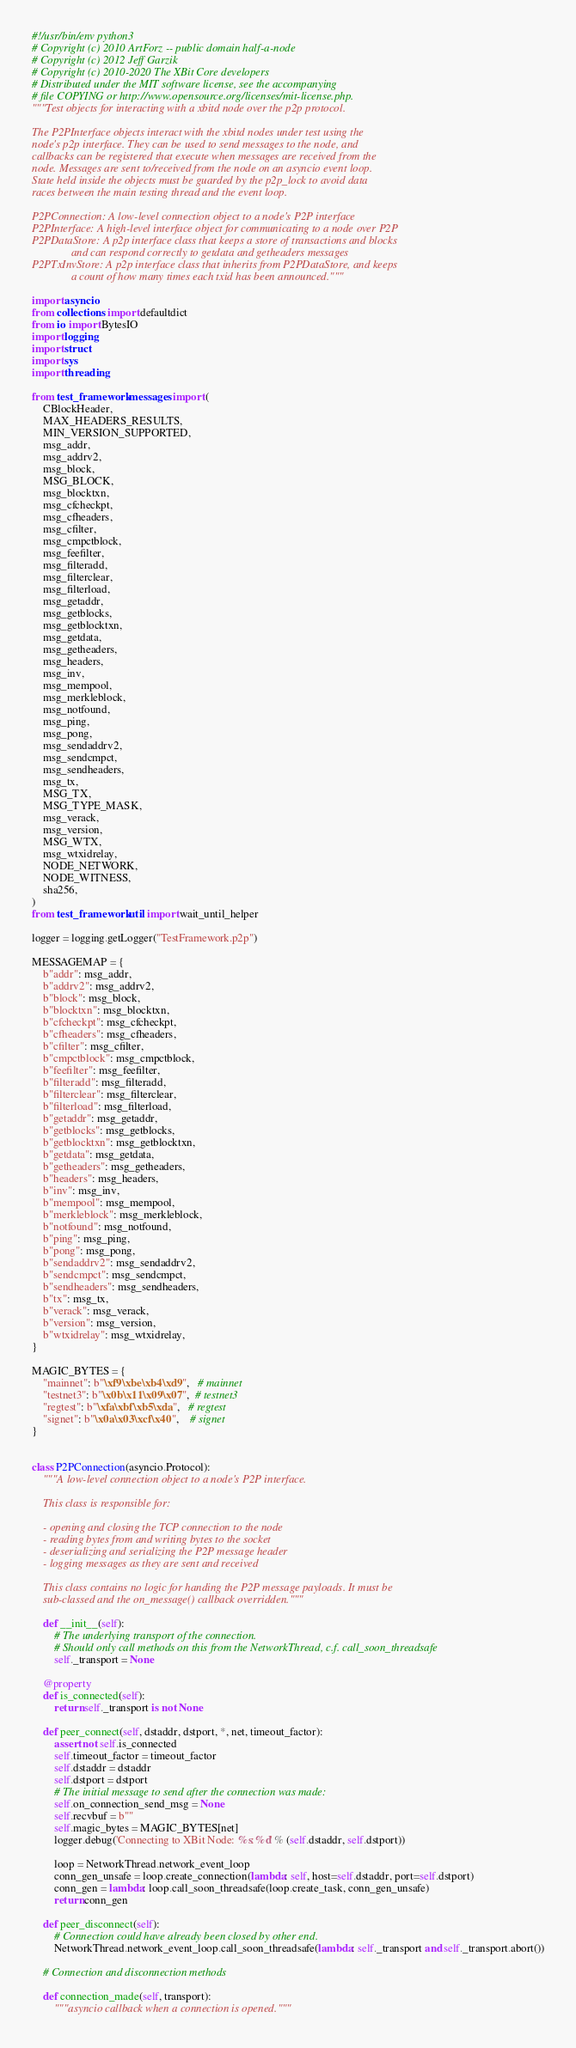Convert code to text. <code><loc_0><loc_0><loc_500><loc_500><_Python_>#!/usr/bin/env python3
# Copyright (c) 2010 ArtForz -- public domain half-a-node
# Copyright (c) 2012 Jeff Garzik
# Copyright (c) 2010-2020 The XBit Core developers
# Distributed under the MIT software license, see the accompanying
# file COPYING or http://www.opensource.org/licenses/mit-license.php.
"""Test objects for interacting with a xbitd node over the p2p protocol.

The P2PInterface objects interact with the xbitd nodes under test using the
node's p2p interface. They can be used to send messages to the node, and
callbacks can be registered that execute when messages are received from the
node. Messages are sent to/received from the node on an asyncio event loop.
State held inside the objects must be guarded by the p2p_lock to avoid data
races between the main testing thread and the event loop.

P2PConnection: A low-level connection object to a node's P2P interface
P2PInterface: A high-level interface object for communicating to a node over P2P
P2PDataStore: A p2p interface class that keeps a store of transactions and blocks
              and can respond correctly to getdata and getheaders messages
P2PTxInvStore: A p2p interface class that inherits from P2PDataStore, and keeps
              a count of how many times each txid has been announced."""

import asyncio
from collections import defaultdict
from io import BytesIO
import logging
import struct
import sys
import threading

from test_framework.messages import (
    CBlockHeader,
    MAX_HEADERS_RESULTS,
    MIN_VERSION_SUPPORTED,
    msg_addr,
    msg_addrv2,
    msg_block,
    MSG_BLOCK,
    msg_blocktxn,
    msg_cfcheckpt,
    msg_cfheaders,
    msg_cfilter,
    msg_cmpctblock,
    msg_feefilter,
    msg_filteradd,
    msg_filterclear,
    msg_filterload,
    msg_getaddr,
    msg_getblocks,
    msg_getblocktxn,
    msg_getdata,
    msg_getheaders,
    msg_headers,
    msg_inv,
    msg_mempool,
    msg_merkleblock,
    msg_notfound,
    msg_ping,
    msg_pong,
    msg_sendaddrv2,
    msg_sendcmpct,
    msg_sendheaders,
    msg_tx,
    MSG_TX,
    MSG_TYPE_MASK,
    msg_verack,
    msg_version,
    MSG_WTX,
    msg_wtxidrelay,
    NODE_NETWORK,
    NODE_WITNESS,
    sha256,
)
from test_framework.util import wait_until_helper

logger = logging.getLogger("TestFramework.p2p")

MESSAGEMAP = {
    b"addr": msg_addr,
    b"addrv2": msg_addrv2,
    b"block": msg_block,
    b"blocktxn": msg_blocktxn,
    b"cfcheckpt": msg_cfcheckpt,
    b"cfheaders": msg_cfheaders,
    b"cfilter": msg_cfilter,
    b"cmpctblock": msg_cmpctblock,
    b"feefilter": msg_feefilter,
    b"filteradd": msg_filteradd,
    b"filterclear": msg_filterclear,
    b"filterload": msg_filterload,
    b"getaddr": msg_getaddr,
    b"getblocks": msg_getblocks,
    b"getblocktxn": msg_getblocktxn,
    b"getdata": msg_getdata,
    b"getheaders": msg_getheaders,
    b"headers": msg_headers,
    b"inv": msg_inv,
    b"mempool": msg_mempool,
    b"merkleblock": msg_merkleblock,
    b"notfound": msg_notfound,
    b"ping": msg_ping,
    b"pong": msg_pong,
    b"sendaddrv2": msg_sendaddrv2,
    b"sendcmpct": msg_sendcmpct,
    b"sendheaders": msg_sendheaders,
    b"tx": msg_tx,
    b"verack": msg_verack,
    b"version": msg_version,
    b"wtxidrelay": msg_wtxidrelay,
}

MAGIC_BYTES = {
    "mainnet": b"\xf9\xbe\xb4\xd9",   # mainnet
    "testnet3": b"\x0b\x11\x09\x07",  # testnet3
    "regtest": b"\xfa\xbf\xb5\xda",   # regtest
    "signet": b"\x0a\x03\xcf\x40",    # signet
}


class P2PConnection(asyncio.Protocol):
    """A low-level connection object to a node's P2P interface.

    This class is responsible for:

    - opening and closing the TCP connection to the node
    - reading bytes from and writing bytes to the socket
    - deserializing and serializing the P2P message header
    - logging messages as they are sent and received

    This class contains no logic for handing the P2P message payloads. It must be
    sub-classed and the on_message() callback overridden."""

    def __init__(self):
        # The underlying transport of the connection.
        # Should only call methods on this from the NetworkThread, c.f. call_soon_threadsafe
        self._transport = None

    @property
    def is_connected(self):
        return self._transport is not None

    def peer_connect(self, dstaddr, dstport, *, net, timeout_factor):
        assert not self.is_connected
        self.timeout_factor = timeout_factor
        self.dstaddr = dstaddr
        self.dstport = dstport
        # The initial message to send after the connection was made:
        self.on_connection_send_msg = None
        self.recvbuf = b""
        self.magic_bytes = MAGIC_BYTES[net]
        logger.debug('Connecting to XBit Node: %s:%d' % (self.dstaddr, self.dstport))

        loop = NetworkThread.network_event_loop
        conn_gen_unsafe = loop.create_connection(lambda: self, host=self.dstaddr, port=self.dstport)
        conn_gen = lambda: loop.call_soon_threadsafe(loop.create_task, conn_gen_unsafe)
        return conn_gen

    def peer_disconnect(self):
        # Connection could have already been closed by other end.
        NetworkThread.network_event_loop.call_soon_threadsafe(lambda: self._transport and self._transport.abort())

    # Connection and disconnection methods

    def connection_made(self, transport):
        """asyncio callback when a connection is opened."""</code> 